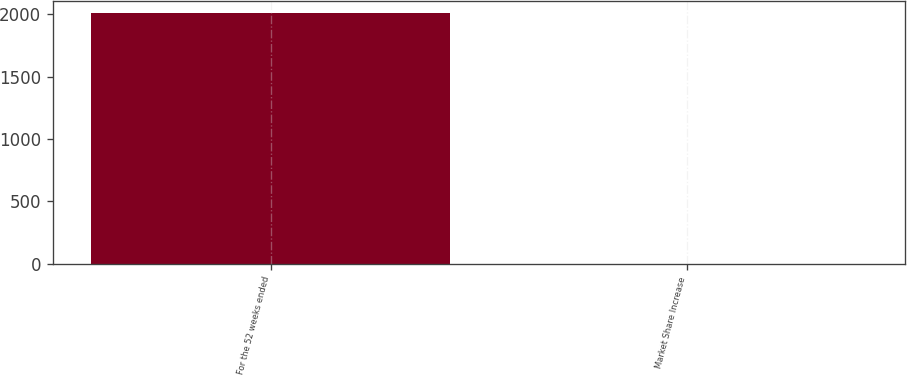Convert chart to OTSL. <chart><loc_0><loc_0><loc_500><loc_500><bar_chart><fcel>For the 52 weeks ended<fcel>Market Share Increase<nl><fcel>2008<fcel>0.2<nl></chart> 